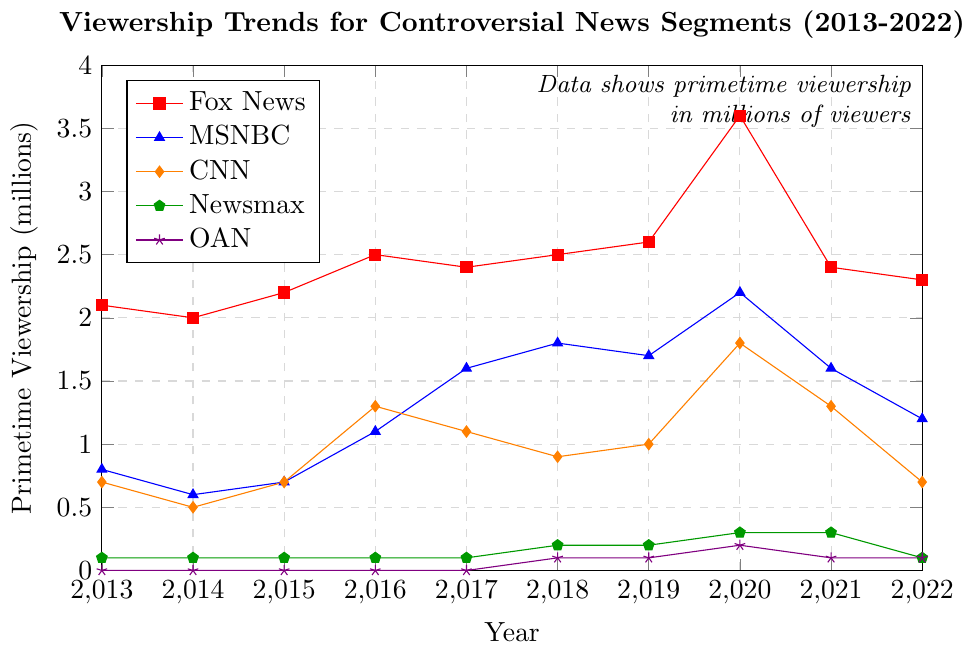What's the trend in Fox News Primetime viewership from 2013 to 2022? Fox News Primetime viewership starts at 2.1 million in 2013, peaks at 3.6 million in 2020, and ends at 2.3 million in 2022. The trend shows an initial rise, a peak in 2020, followed by a decline.
Answer: Rising initially, peaks in 2020, then declines Which year saw the highest combined viewership for all channels? Adding the viewership for all channels for each year, 2020 has the highest combined total: (3.6 + 2.2 + 1.8 + 0.3 + 0.2) million viewers = 8.1 million viewers.
Answer: 2020 How does MSNBC Primetime viewership in 2021 compare to its viewership in 2016? MSNBC had 1.6 million viewers in 2021 compared to 1.1 million viewers in 2016.
Answer: Higher in 2021 Which channel experienced the most significant peak in viewership in a single year? Fox News had the most significant peak in viewership, jumping to 3.6 million viewers in 2020, the highest single-year increase.
Answer: Fox News What is the average viewership of Newsmax from 2013 to 2022? Adding up all the yearly viewership totals for Newsmax from 2013 to 2022: (0.1 + 0.1 + 0.1 + 0.1 + 0.1 + 0.2 + 0.2 + 0.3 + 0.3 + 0.1) = 1.6 million viewers. Dividing by the 10 years gives: 1.6 million / 10 = 0.16 million viewers.
Answer: 0.16 million Did CNN Primetime viewership show a consistent upward trend from 2013 to 2022? The viewership for CNN Primetime increased erratically. It was 0.7 million in 2013, peaking at 1.8 million in 2020, then dropping to 0.7 million in 2022.
Answer: No Which network shows a relatively stable viewership throughout the period from 2013 to 2022? Based on visual inspection, OAN shows relatively stable viewership, starting with 0.0 million in 2013, peaking at 0.2 million in 2020, and ending at 0.1 million in 2022 without significant fluctuations.
Answer: OAN By how many millions did Fox News Primetime viewership increase from 2019 to 2020? Fox News Primetime viewership increased from 2.6 million in 2019 to 3.6 million in 2020. The difference is 3.6 - 2.6 = 1 million.
Answer: 1 million Compare the viewership trend of MSNBC and Fox News from 2016 to 2020. From 2016 to 2020, Fox News viewership rose from 2.5 million to 3.6 million, while MSNBC’s viewership grew from 1.1 million to 2.2 million. Both networks show an upward trend, with Fox News showing a larger increase.
Answer: Both increasing, Fox News larger increase 